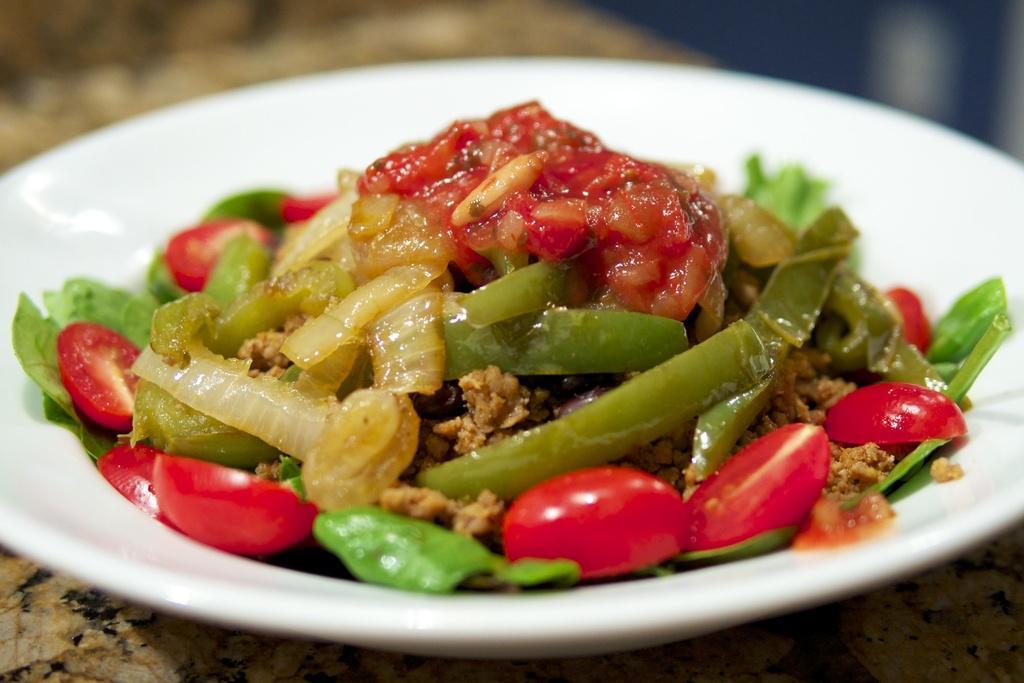Can you describe this image briefly? In this picture we can see a plate with food items on it such as onion and tomato pieces and this plate is placed on a platform. 